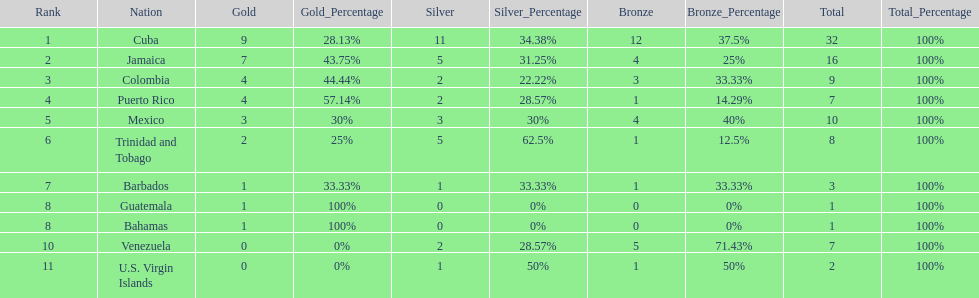Largest medal differential between countries 31. 